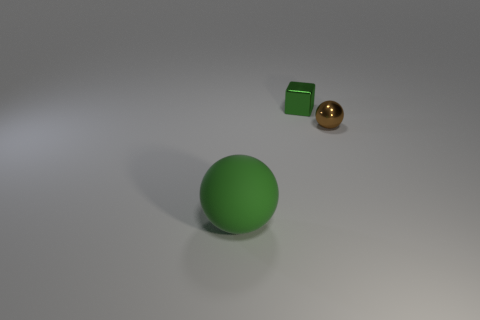Subtract all blocks. How many objects are left? 2 Add 3 tiny yellow matte things. How many objects exist? 6 Add 2 tiny brown spheres. How many tiny brown spheres are left? 3 Add 1 brown metallic things. How many brown metallic things exist? 2 Subtract 0 gray balls. How many objects are left? 3 Subtract all small gray cubes. Subtract all spheres. How many objects are left? 1 